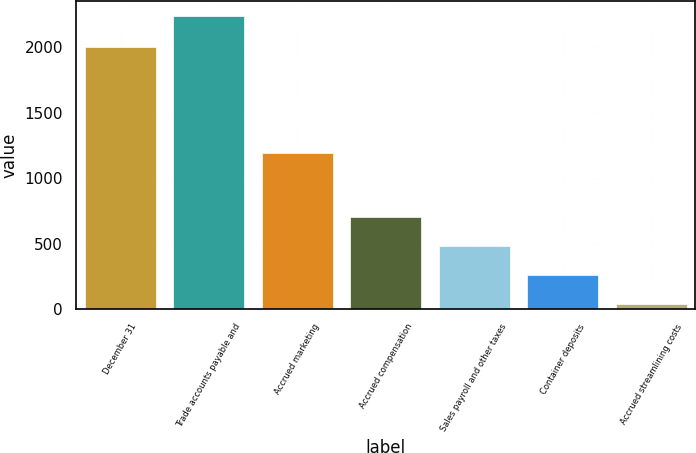Convert chart to OTSL. <chart><loc_0><loc_0><loc_500><loc_500><bar_chart><fcel>December 31<fcel>Trade accounts payable and<fcel>Accrued marketing<fcel>Accrued compensation<fcel>Sales payroll and other taxes<fcel>Container deposits<fcel>Accrued streamlining costs<nl><fcel>2004<fcel>2238<fcel>1194<fcel>700.1<fcel>480.4<fcel>260.7<fcel>41<nl></chart> 